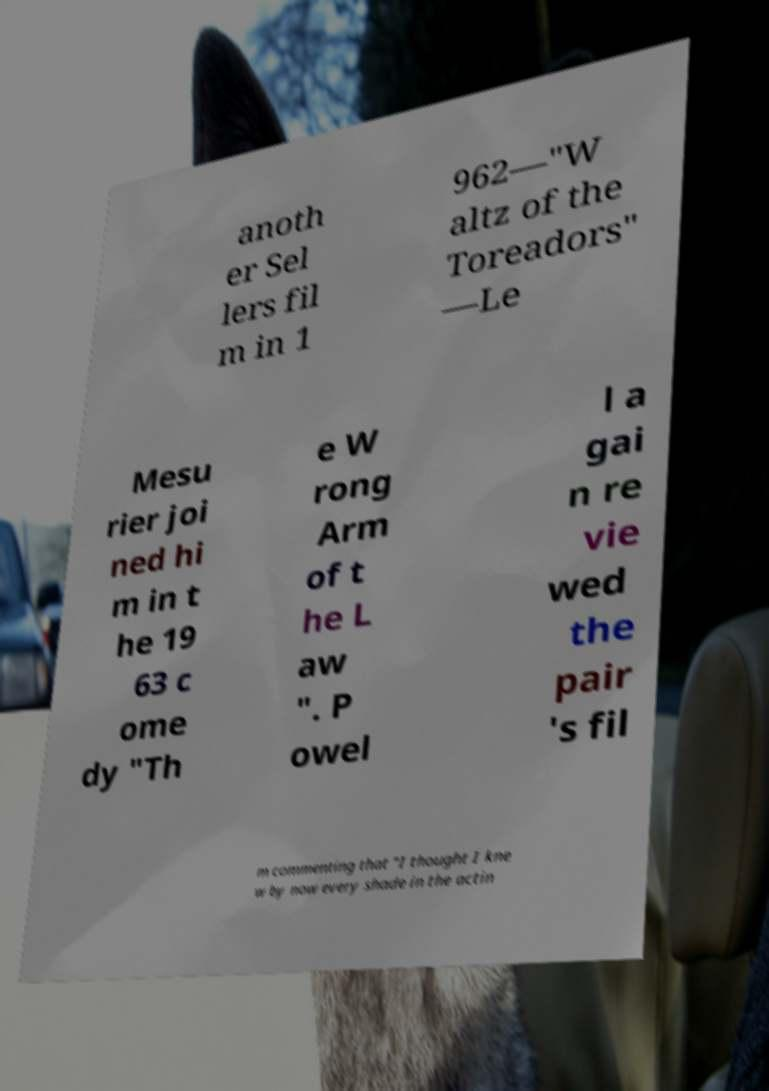What messages or text are displayed in this image? I need them in a readable, typed format. anoth er Sel lers fil m in 1 962—"W altz of the Toreadors" —Le Mesu rier joi ned hi m in t he 19 63 c ome dy "Th e W rong Arm of t he L aw ". P owel l a gai n re vie wed the pair 's fil m commenting that "I thought I kne w by now every shade in the actin 